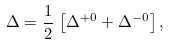<formula> <loc_0><loc_0><loc_500><loc_500>\Delta = \frac { 1 } { 2 } \, \left [ \Delta ^ { + 0 } + \Delta ^ { - 0 } \right ] ,</formula> 